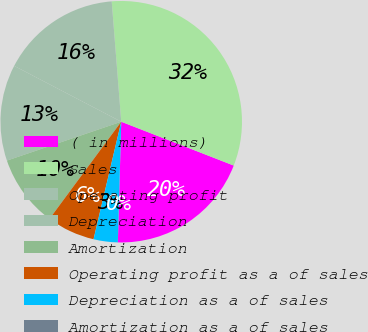Convert chart to OTSL. <chart><loc_0><loc_0><loc_500><loc_500><pie_chart><fcel>( in millions)<fcel>Sales<fcel>Operating profit<fcel>Depreciation<fcel>Amortization<fcel>Operating profit as a of sales<fcel>Depreciation as a of sales<fcel>Amortization as a of sales<nl><fcel>19.53%<fcel>32.17%<fcel>16.09%<fcel>12.87%<fcel>9.66%<fcel>6.44%<fcel>3.23%<fcel>0.01%<nl></chart> 